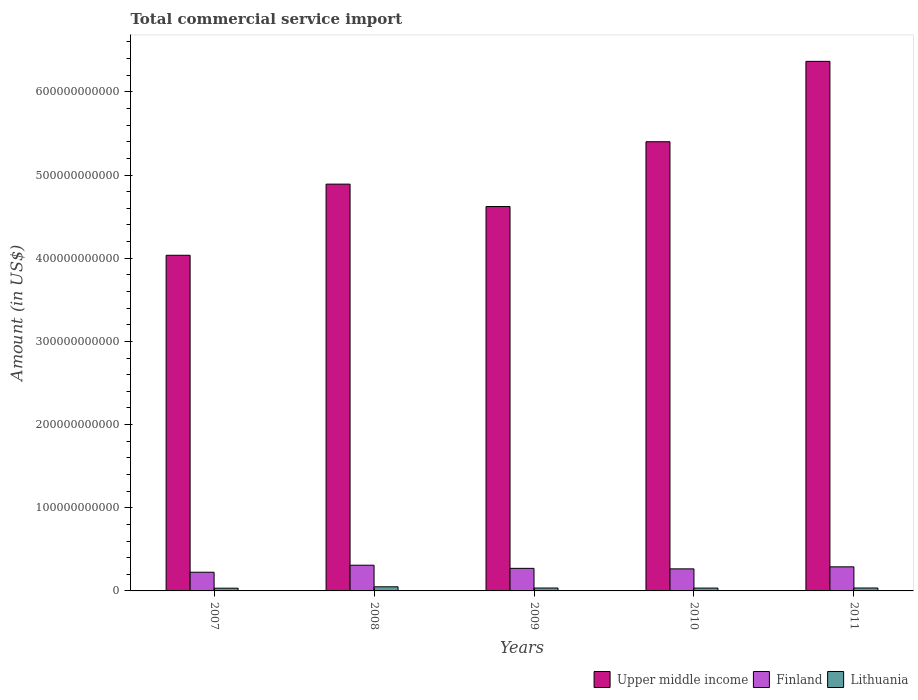How many different coloured bars are there?
Make the answer very short. 3. Are the number of bars per tick equal to the number of legend labels?
Provide a succinct answer. Yes. Are the number of bars on each tick of the X-axis equal?
Keep it short and to the point. Yes. How many bars are there on the 5th tick from the left?
Your answer should be very brief. 3. How many bars are there on the 4th tick from the right?
Offer a terse response. 3. What is the total commercial service import in Lithuania in 2009?
Provide a short and direct response. 3.48e+09. Across all years, what is the maximum total commercial service import in Upper middle income?
Ensure brevity in your answer.  6.37e+11. Across all years, what is the minimum total commercial service import in Upper middle income?
Offer a very short reply. 4.04e+11. In which year was the total commercial service import in Upper middle income minimum?
Your answer should be very brief. 2007. What is the total total commercial service import in Upper middle income in the graph?
Offer a terse response. 2.53e+12. What is the difference between the total commercial service import in Lithuania in 2008 and that in 2011?
Offer a very short reply. 1.44e+09. What is the difference between the total commercial service import in Finland in 2007 and the total commercial service import in Lithuania in 2009?
Provide a succinct answer. 1.90e+1. What is the average total commercial service import in Upper middle income per year?
Your answer should be very brief. 5.06e+11. In the year 2008, what is the difference between the total commercial service import in Finland and total commercial service import in Upper middle income?
Your answer should be very brief. -4.58e+11. What is the ratio of the total commercial service import in Upper middle income in 2009 to that in 2011?
Provide a short and direct response. 0.73. Is the total commercial service import in Lithuania in 2007 less than that in 2011?
Make the answer very short. Yes. Is the difference between the total commercial service import in Finland in 2008 and 2010 greater than the difference between the total commercial service import in Upper middle income in 2008 and 2010?
Make the answer very short. Yes. What is the difference between the highest and the second highest total commercial service import in Finland?
Your response must be concise. 1.96e+09. What is the difference between the highest and the lowest total commercial service import in Finland?
Make the answer very short. 8.45e+09. What does the 1st bar from the left in 2007 represents?
Give a very brief answer. Upper middle income. What does the 3rd bar from the right in 2008 represents?
Offer a terse response. Upper middle income. Are all the bars in the graph horizontal?
Ensure brevity in your answer.  No. How many years are there in the graph?
Your response must be concise. 5. What is the difference between two consecutive major ticks on the Y-axis?
Offer a very short reply. 1.00e+11. What is the title of the graph?
Your answer should be very brief. Total commercial service import. Does "American Samoa" appear as one of the legend labels in the graph?
Offer a very short reply. No. What is the label or title of the X-axis?
Ensure brevity in your answer.  Years. What is the label or title of the Y-axis?
Give a very brief answer. Amount (in US$). What is the Amount (in US$) of Upper middle income in 2007?
Provide a succinct answer. 4.04e+11. What is the Amount (in US$) in Finland in 2007?
Your answer should be very brief. 2.25e+1. What is the Amount (in US$) in Lithuania in 2007?
Provide a succinct answer. 3.28e+09. What is the Amount (in US$) of Upper middle income in 2008?
Keep it short and to the point. 4.89e+11. What is the Amount (in US$) of Finland in 2008?
Give a very brief answer. 3.09e+1. What is the Amount (in US$) in Lithuania in 2008?
Give a very brief answer. 4.95e+09. What is the Amount (in US$) of Upper middle income in 2009?
Offer a very short reply. 4.62e+11. What is the Amount (in US$) of Finland in 2009?
Your response must be concise. 2.71e+1. What is the Amount (in US$) of Lithuania in 2009?
Offer a terse response. 3.48e+09. What is the Amount (in US$) of Upper middle income in 2010?
Make the answer very short. 5.40e+11. What is the Amount (in US$) in Finland in 2010?
Provide a succinct answer. 2.65e+1. What is the Amount (in US$) of Lithuania in 2010?
Your response must be concise. 3.40e+09. What is the Amount (in US$) in Upper middle income in 2011?
Provide a succinct answer. 6.37e+11. What is the Amount (in US$) in Finland in 2011?
Make the answer very short. 2.90e+1. What is the Amount (in US$) of Lithuania in 2011?
Provide a short and direct response. 3.51e+09. Across all years, what is the maximum Amount (in US$) of Upper middle income?
Give a very brief answer. 6.37e+11. Across all years, what is the maximum Amount (in US$) in Finland?
Offer a very short reply. 3.09e+1. Across all years, what is the maximum Amount (in US$) of Lithuania?
Make the answer very short. 4.95e+09. Across all years, what is the minimum Amount (in US$) in Upper middle income?
Provide a succinct answer. 4.04e+11. Across all years, what is the minimum Amount (in US$) of Finland?
Your answer should be compact. 2.25e+1. Across all years, what is the minimum Amount (in US$) of Lithuania?
Your response must be concise. 3.28e+09. What is the total Amount (in US$) in Upper middle income in the graph?
Give a very brief answer. 2.53e+12. What is the total Amount (in US$) of Finland in the graph?
Your response must be concise. 1.36e+11. What is the total Amount (in US$) in Lithuania in the graph?
Ensure brevity in your answer.  1.86e+1. What is the difference between the Amount (in US$) of Upper middle income in 2007 and that in 2008?
Your answer should be very brief. -8.55e+1. What is the difference between the Amount (in US$) in Finland in 2007 and that in 2008?
Your answer should be compact. -8.45e+09. What is the difference between the Amount (in US$) of Lithuania in 2007 and that in 2008?
Offer a terse response. -1.67e+09. What is the difference between the Amount (in US$) in Upper middle income in 2007 and that in 2009?
Ensure brevity in your answer.  -5.86e+1. What is the difference between the Amount (in US$) in Finland in 2007 and that in 2009?
Provide a succinct answer. -4.66e+09. What is the difference between the Amount (in US$) of Lithuania in 2007 and that in 2009?
Provide a short and direct response. -2.01e+08. What is the difference between the Amount (in US$) of Upper middle income in 2007 and that in 2010?
Offer a very short reply. -1.37e+11. What is the difference between the Amount (in US$) in Finland in 2007 and that in 2010?
Ensure brevity in your answer.  -4.05e+09. What is the difference between the Amount (in US$) of Lithuania in 2007 and that in 2010?
Offer a terse response. -1.26e+08. What is the difference between the Amount (in US$) of Upper middle income in 2007 and that in 2011?
Ensure brevity in your answer.  -2.33e+11. What is the difference between the Amount (in US$) of Finland in 2007 and that in 2011?
Your answer should be compact. -6.48e+09. What is the difference between the Amount (in US$) in Lithuania in 2007 and that in 2011?
Keep it short and to the point. -2.30e+08. What is the difference between the Amount (in US$) of Upper middle income in 2008 and that in 2009?
Give a very brief answer. 2.69e+1. What is the difference between the Amount (in US$) of Finland in 2008 and that in 2009?
Provide a short and direct response. 3.79e+09. What is the difference between the Amount (in US$) of Lithuania in 2008 and that in 2009?
Make the answer very short. 1.47e+09. What is the difference between the Amount (in US$) of Upper middle income in 2008 and that in 2010?
Offer a very short reply. -5.10e+1. What is the difference between the Amount (in US$) in Finland in 2008 and that in 2010?
Your response must be concise. 4.40e+09. What is the difference between the Amount (in US$) in Lithuania in 2008 and that in 2010?
Ensure brevity in your answer.  1.55e+09. What is the difference between the Amount (in US$) of Upper middle income in 2008 and that in 2011?
Give a very brief answer. -1.48e+11. What is the difference between the Amount (in US$) of Finland in 2008 and that in 2011?
Provide a succinct answer. 1.96e+09. What is the difference between the Amount (in US$) of Lithuania in 2008 and that in 2011?
Offer a very short reply. 1.44e+09. What is the difference between the Amount (in US$) of Upper middle income in 2009 and that in 2010?
Ensure brevity in your answer.  -7.79e+1. What is the difference between the Amount (in US$) of Finland in 2009 and that in 2010?
Keep it short and to the point. 6.09e+08. What is the difference between the Amount (in US$) of Lithuania in 2009 and that in 2010?
Make the answer very short. 7.47e+07. What is the difference between the Amount (in US$) of Upper middle income in 2009 and that in 2011?
Give a very brief answer. -1.75e+11. What is the difference between the Amount (in US$) of Finland in 2009 and that in 2011?
Give a very brief answer. -1.82e+09. What is the difference between the Amount (in US$) of Lithuania in 2009 and that in 2011?
Offer a very short reply. -2.92e+07. What is the difference between the Amount (in US$) of Upper middle income in 2010 and that in 2011?
Ensure brevity in your answer.  -9.66e+1. What is the difference between the Amount (in US$) of Finland in 2010 and that in 2011?
Offer a very short reply. -2.43e+09. What is the difference between the Amount (in US$) of Lithuania in 2010 and that in 2011?
Your answer should be compact. -1.04e+08. What is the difference between the Amount (in US$) in Upper middle income in 2007 and the Amount (in US$) in Finland in 2008?
Keep it short and to the point. 3.73e+11. What is the difference between the Amount (in US$) of Upper middle income in 2007 and the Amount (in US$) of Lithuania in 2008?
Your answer should be compact. 3.99e+11. What is the difference between the Amount (in US$) of Finland in 2007 and the Amount (in US$) of Lithuania in 2008?
Your answer should be very brief. 1.75e+1. What is the difference between the Amount (in US$) in Upper middle income in 2007 and the Amount (in US$) in Finland in 2009?
Offer a terse response. 3.76e+11. What is the difference between the Amount (in US$) of Upper middle income in 2007 and the Amount (in US$) of Lithuania in 2009?
Make the answer very short. 4.00e+11. What is the difference between the Amount (in US$) of Finland in 2007 and the Amount (in US$) of Lithuania in 2009?
Your response must be concise. 1.90e+1. What is the difference between the Amount (in US$) of Upper middle income in 2007 and the Amount (in US$) of Finland in 2010?
Your answer should be very brief. 3.77e+11. What is the difference between the Amount (in US$) of Upper middle income in 2007 and the Amount (in US$) of Lithuania in 2010?
Offer a terse response. 4.00e+11. What is the difference between the Amount (in US$) in Finland in 2007 and the Amount (in US$) in Lithuania in 2010?
Give a very brief answer. 1.91e+1. What is the difference between the Amount (in US$) of Upper middle income in 2007 and the Amount (in US$) of Finland in 2011?
Your answer should be compact. 3.75e+11. What is the difference between the Amount (in US$) of Upper middle income in 2007 and the Amount (in US$) of Lithuania in 2011?
Your response must be concise. 4.00e+11. What is the difference between the Amount (in US$) in Finland in 2007 and the Amount (in US$) in Lithuania in 2011?
Provide a short and direct response. 1.90e+1. What is the difference between the Amount (in US$) of Upper middle income in 2008 and the Amount (in US$) of Finland in 2009?
Provide a short and direct response. 4.62e+11. What is the difference between the Amount (in US$) of Upper middle income in 2008 and the Amount (in US$) of Lithuania in 2009?
Provide a short and direct response. 4.86e+11. What is the difference between the Amount (in US$) of Finland in 2008 and the Amount (in US$) of Lithuania in 2009?
Offer a very short reply. 2.74e+1. What is the difference between the Amount (in US$) of Upper middle income in 2008 and the Amount (in US$) of Finland in 2010?
Make the answer very short. 4.63e+11. What is the difference between the Amount (in US$) in Upper middle income in 2008 and the Amount (in US$) in Lithuania in 2010?
Ensure brevity in your answer.  4.86e+11. What is the difference between the Amount (in US$) in Finland in 2008 and the Amount (in US$) in Lithuania in 2010?
Make the answer very short. 2.75e+1. What is the difference between the Amount (in US$) in Upper middle income in 2008 and the Amount (in US$) in Finland in 2011?
Offer a terse response. 4.60e+11. What is the difference between the Amount (in US$) of Upper middle income in 2008 and the Amount (in US$) of Lithuania in 2011?
Offer a very short reply. 4.86e+11. What is the difference between the Amount (in US$) of Finland in 2008 and the Amount (in US$) of Lithuania in 2011?
Give a very brief answer. 2.74e+1. What is the difference between the Amount (in US$) in Upper middle income in 2009 and the Amount (in US$) in Finland in 2010?
Make the answer very short. 4.36e+11. What is the difference between the Amount (in US$) of Upper middle income in 2009 and the Amount (in US$) of Lithuania in 2010?
Your answer should be very brief. 4.59e+11. What is the difference between the Amount (in US$) of Finland in 2009 and the Amount (in US$) of Lithuania in 2010?
Offer a terse response. 2.37e+1. What is the difference between the Amount (in US$) in Upper middle income in 2009 and the Amount (in US$) in Finland in 2011?
Make the answer very short. 4.33e+11. What is the difference between the Amount (in US$) of Upper middle income in 2009 and the Amount (in US$) of Lithuania in 2011?
Ensure brevity in your answer.  4.59e+11. What is the difference between the Amount (in US$) of Finland in 2009 and the Amount (in US$) of Lithuania in 2011?
Offer a very short reply. 2.36e+1. What is the difference between the Amount (in US$) of Upper middle income in 2010 and the Amount (in US$) of Finland in 2011?
Offer a very short reply. 5.11e+11. What is the difference between the Amount (in US$) in Upper middle income in 2010 and the Amount (in US$) in Lithuania in 2011?
Your response must be concise. 5.37e+11. What is the difference between the Amount (in US$) of Finland in 2010 and the Amount (in US$) of Lithuania in 2011?
Offer a terse response. 2.30e+1. What is the average Amount (in US$) in Upper middle income per year?
Provide a succinct answer. 5.06e+11. What is the average Amount (in US$) of Finland per year?
Your answer should be compact. 2.72e+1. What is the average Amount (in US$) in Lithuania per year?
Your response must be concise. 3.72e+09. In the year 2007, what is the difference between the Amount (in US$) of Upper middle income and Amount (in US$) of Finland?
Offer a very short reply. 3.81e+11. In the year 2007, what is the difference between the Amount (in US$) of Upper middle income and Amount (in US$) of Lithuania?
Your answer should be very brief. 4.00e+11. In the year 2007, what is the difference between the Amount (in US$) of Finland and Amount (in US$) of Lithuania?
Give a very brief answer. 1.92e+1. In the year 2008, what is the difference between the Amount (in US$) in Upper middle income and Amount (in US$) in Finland?
Keep it short and to the point. 4.58e+11. In the year 2008, what is the difference between the Amount (in US$) in Upper middle income and Amount (in US$) in Lithuania?
Make the answer very short. 4.84e+11. In the year 2008, what is the difference between the Amount (in US$) in Finland and Amount (in US$) in Lithuania?
Your answer should be very brief. 2.60e+1. In the year 2009, what is the difference between the Amount (in US$) in Upper middle income and Amount (in US$) in Finland?
Your response must be concise. 4.35e+11. In the year 2009, what is the difference between the Amount (in US$) of Upper middle income and Amount (in US$) of Lithuania?
Give a very brief answer. 4.59e+11. In the year 2009, what is the difference between the Amount (in US$) of Finland and Amount (in US$) of Lithuania?
Keep it short and to the point. 2.37e+1. In the year 2010, what is the difference between the Amount (in US$) of Upper middle income and Amount (in US$) of Finland?
Give a very brief answer. 5.14e+11. In the year 2010, what is the difference between the Amount (in US$) in Upper middle income and Amount (in US$) in Lithuania?
Give a very brief answer. 5.37e+11. In the year 2010, what is the difference between the Amount (in US$) in Finland and Amount (in US$) in Lithuania?
Keep it short and to the point. 2.31e+1. In the year 2011, what is the difference between the Amount (in US$) of Upper middle income and Amount (in US$) of Finland?
Provide a short and direct response. 6.08e+11. In the year 2011, what is the difference between the Amount (in US$) in Upper middle income and Amount (in US$) in Lithuania?
Your response must be concise. 6.33e+11. In the year 2011, what is the difference between the Amount (in US$) of Finland and Amount (in US$) of Lithuania?
Provide a succinct answer. 2.54e+1. What is the ratio of the Amount (in US$) in Upper middle income in 2007 to that in 2008?
Give a very brief answer. 0.83. What is the ratio of the Amount (in US$) in Finland in 2007 to that in 2008?
Keep it short and to the point. 0.73. What is the ratio of the Amount (in US$) in Lithuania in 2007 to that in 2008?
Make the answer very short. 0.66. What is the ratio of the Amount (in US$) of Upper middle income in 2007 to that in 2009?
Ensure brevity in your answer.  0.87. What is the ratio of the Amount (in US$) of Finland in 2007 to that in 2009?
Offer a terse response. 0.83. What is the ratio of the Amount (in US$) in Lithuania in 2007 to that in 2009?
Give a very brief answer. 0.94. What is the ratio of the Amount (in US$) of Upper middle income in 2007 to that in 2010?
Offer a terse response. 0.75. What is the ratio of the Amount (in US$) of Finland in 2007 to that in 2010?
Provide a short and direct response. 0.85. What is the ratio of the Amount (in US$) in Lithuania in 2007 to that in 2010?
Provide a succinct answer. 0.96. What is the ratio of the Amount (in US$) of Upper middle income in 2007 to that in 2011?
Offer a very short reply. 0.63. What is the ratio of the Amount (in US$) of Finland in 2007 to that in 2011?
Provide a succinct answer. 0.78. What is the ratio of the Amount (in US$) in Lithuania in 2007 to that in 2011?
Your answer should be compact. 0.93. What is the ratio of the Amount (in US$) of Upper middle income in 2008 to that in 2009?
Give a very brief answer. 1.06. What is the ratio of the Amount (in US$) in Finland in 2008 to that in 2009?
Offer a terse response. 1.14. What is the ratio of the Amount (in US$) in Lithuania in 2008 to that in 2009?
Give a very brief answer. 1.42. What is the ratio of the Amount (in US$) in Upper middle income in 2008 to that in 2010?
Give a very brief answer. 0.91. What is the ratio of the Amount (in US$) in Finland in 2008 to that in 2010?
Offer a terse response. 1.17. What is the ratio of the Amount (in US$) of Lithuania in 2008 to that in 2010?
Give a very brief answer. 1.45. What is the ratio of the Amount (in US$) of Upper middle income in 2008 to that in 2011?
Ensure brevity in your answer.  0.77. What is the ratio of the Amount (in US$) of Finland in 2008 to that in 2011?
Ensure brevity in your answer.  1.07. What is the ratio of the Amount (in US$) of Lithuania in 2008 to that in 2011?
Your answer should be very brief. 1.41. What is the ratio of the Amount (in US$) in Upper middle income in 2009 to that in 2010?
Ensure brevity in your answer.  0.86. What is the ratio of the Amount (in US$) in Lithuania in 2009 to that in 2010?
Make the answer very short. 1.02. What is the ratio of the Amount (in US$) in Upper middle income in 2009 to that in 2011?
Offer a terse response. 0.73. What is the ratio of the Amount (in US$) in Finland in 2009 to that in 2011?
Make the answer very short. 0.94. What is the ratio of the Amount (in US$) in Upper middle income in 2010 to that in 2011?
Offer a terse response. 0.85. What is the ratio of the Amount (in US$) in Finland in 2010 to that in 2011?
Make the answer very short. 0.92. What is the ratio of the Amount (in US$) of Lithuania in 2010 to that in 2011?
Your answer should be very brief. 0.97. What is the difference between the highest and the second highest Amount (in US$) of Upper middle income?
Keep it short and to the point. 9.66e+1. What is the difference between the highest and the second highest Amount (in US$) in Finland?
Keep it short and to the point. 1.96e+09. What is the difference between the highest and the second highest Amount (in US$) of Lithuania?
Your answer should be compact. 1.44e+09. What is the difference between the highest and the lowest Amount (in US$) in Upper middle income?
Keep it short and to the point. 2.33e+11. What is the difference between the highest and the lowest Amount (in US$) in Finland?
Your answer should be very brief. 8.45e+09. What is the difference between the highest and the lowest Amount (in US$) of Lithuania?
Give a very brief answer. 1.67e+09. 